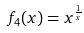Convert formula to latex. <formula><loc_0><loc_0><loc_500><loc_500>f _ { 4 } ( x ) = x ^ { \frac { 1 } { x } }</formula> 